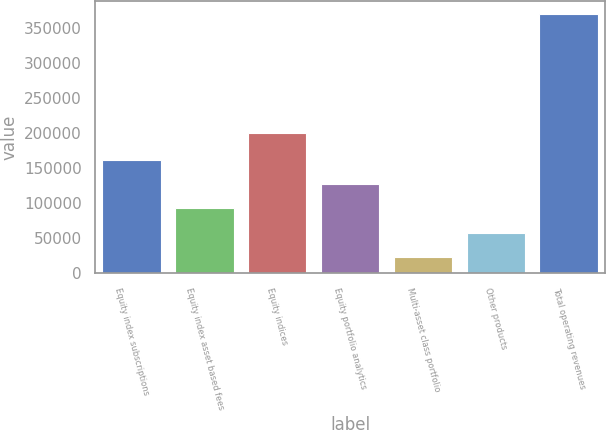Convert chart to OTSL. <chart><loc_0><loc_0><loc_500><loc_500><bar_chart><fcel>Equity index subscriptions<fcel>Equity index asset based fees<fcel>Equity indices<fcel>Equity portfolio analytics<fcel>Multi-asset class portfolio<fcel>Other products<fcel>Total operating revenues<nl><fcel>161796<fcel>92433.2<fcel>199992<fcel>127115<fcel>23070<fcel>57751.6<fcel>369886<nl></chart> 